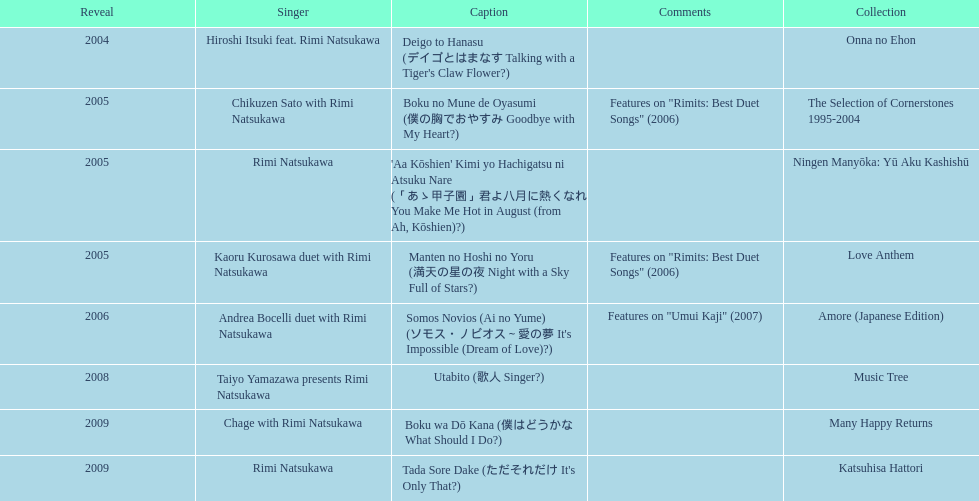Which was not launched in 2004, onna no ehon or music tree? Music Tree. 